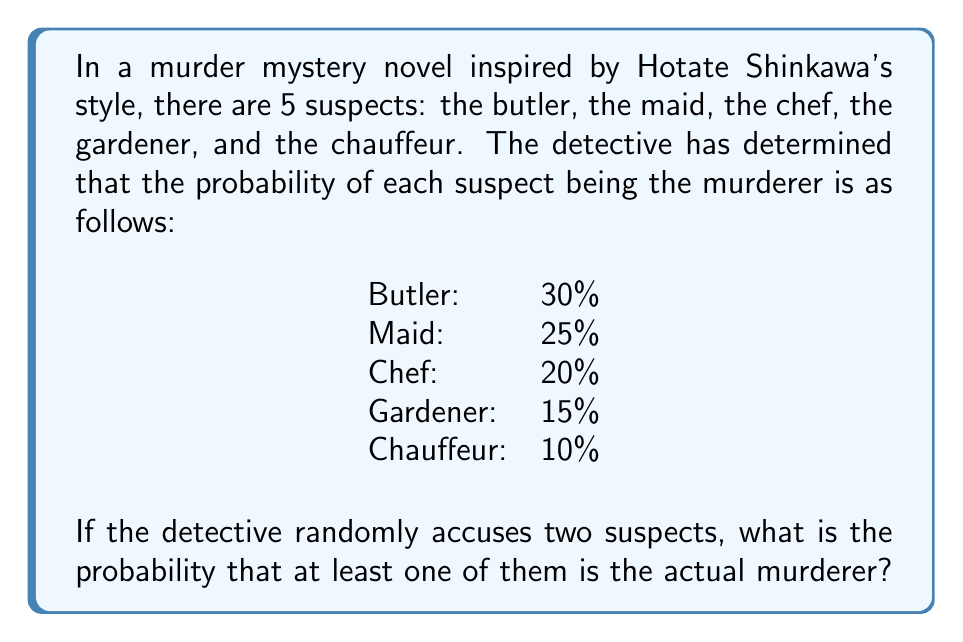Can you answer this question? Let's approach this step-by-step:

1) First, we need to calculate the probability that neither of the two randomly accused suspects is the murderer. This is easier than calculating the probability that at least one of them is the murderer directly.

2) The probability of not choosing the murderer on the first accusation is the sum of the probabilities of all suspects except the actual murderer. This can be calculated as:

   $1 - P(\text{murderer})$

3) The probability of not choosing the murderer on both accusations is the product of not choosing the murderer on the first accusation and not choosing the murderer on the second accusation, given that the first accusation was not the murderer.

4) Let's calculate this:

   $P(\text{neither is murderer}) = (1 - 0.30) \times (1 - \frac{0.25}{0.70}) = 0.70 \times 0.6429 = 0.4500$

5) Therefore, the probability that at least one of the accused is the murderer is:

   $P(\text{at least one is murderer}) = 1 - P(\text{neither is murderer}) = 1 - 0.4500 = 0.5500$

6) Converting to a percentage:

   $0.5500 \times 100\% = 55.00\%$
Answer: 55.00% 